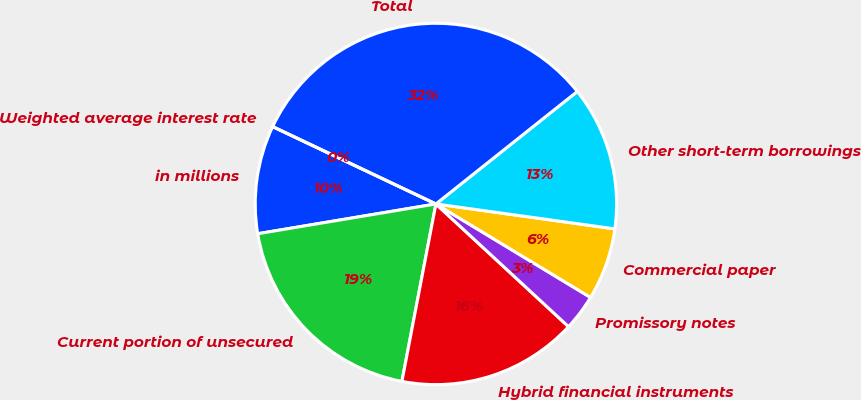Convert chart to OTSL. <chart><loc_0><loc_0><loc_500><loc_500><pie_chart><fcel>in millions<fcel>Current portion of unsecured<fcel>Hybrid financial instruments<fcel>Promissory notes<fcel>Commercial paper<fcel>Other short-term borrowings<fcel>Total<fcel>Weighted average interest rate<nl><fcel>9.68%<fcel>19.35%<fcel>16.13%<fcel>3.23%<fcel>6.45%<fcel>12.9%<fcel>32.26%<fcel>0.0%<nl></chart> 